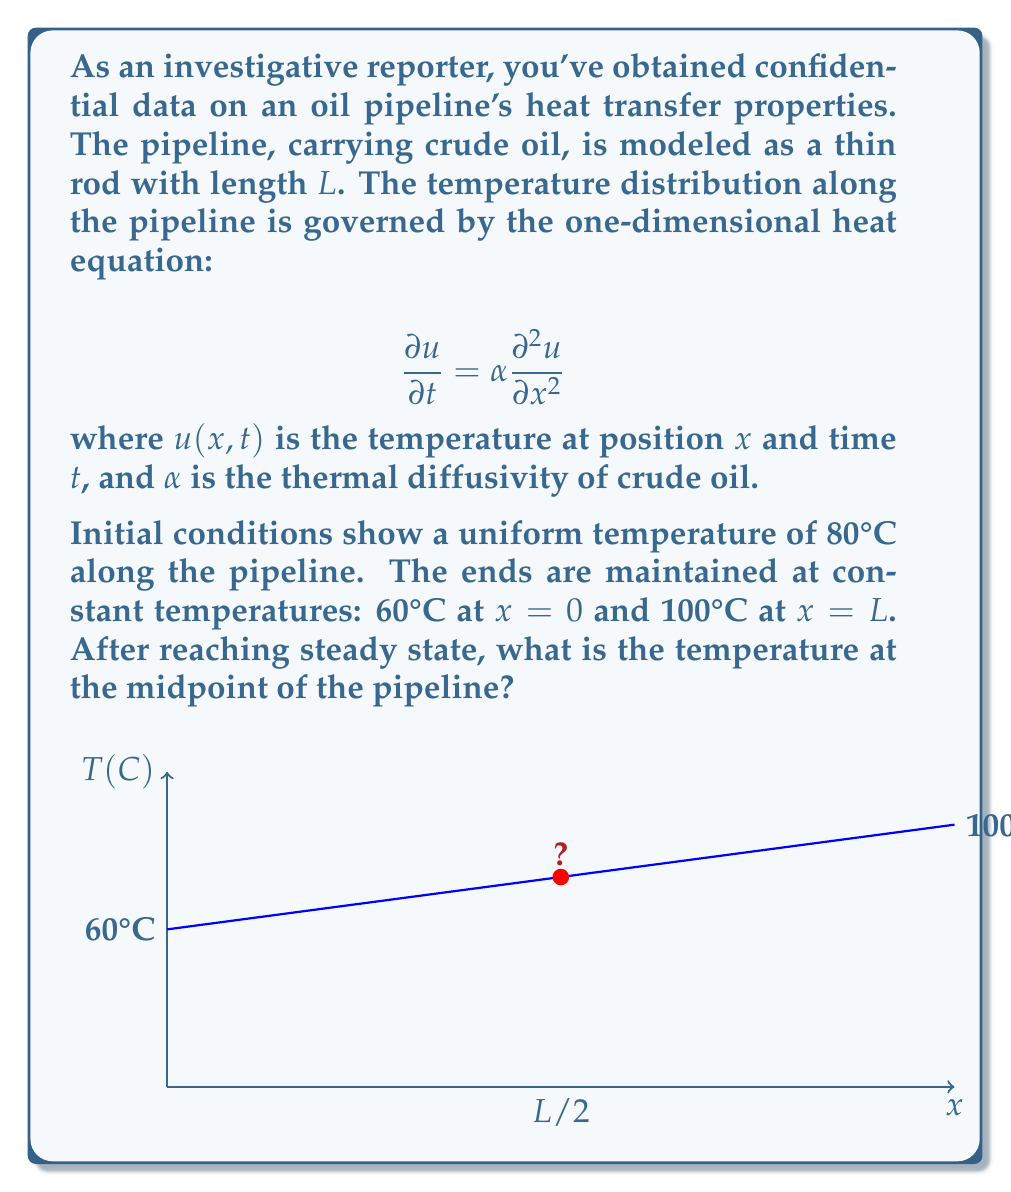Teach me how to tackle this problem. To solve this problem, we need to follow these steps:

1) In steady state, the temperature distribution doesn't change with time. So, we can set $\frac{\partial u}{\partial t} = 0$ in the heat equation:

   $$0 = \alpha \frac{\partial^2 u}{\partial x^2}$$

2) This simplifies to:

   $$\frac{\partial^2 u}{\partial x^2} = 0$$

3) Integrating twice with respect to $x$:

   $$u(x) = Ax + B$$

   where $A$ and $B$ are constants to be determined from the boundary conditions.

4) Apply the boundary conditions:
   At $x = 0$, $u(0) = 60$, so $B = 60$
   At $x = L$, $u(L) = 100$, so $AL + 60 = 100$

5) Solving for $A$:

   $$A = \frac{100 - 60}{L} = \frac{40}{L}$$

6) Therefore, the steady-state temperature distribution is:

   $$u(x) = \frac{40x}{L} + 60$$

7) At the midpoint, $x = L/2$. Substituting this:

   $$u(L/2) = \frac{40(L/2)}{L} + 60 = 20 + 60 = 80$$
Answer: 80°C 